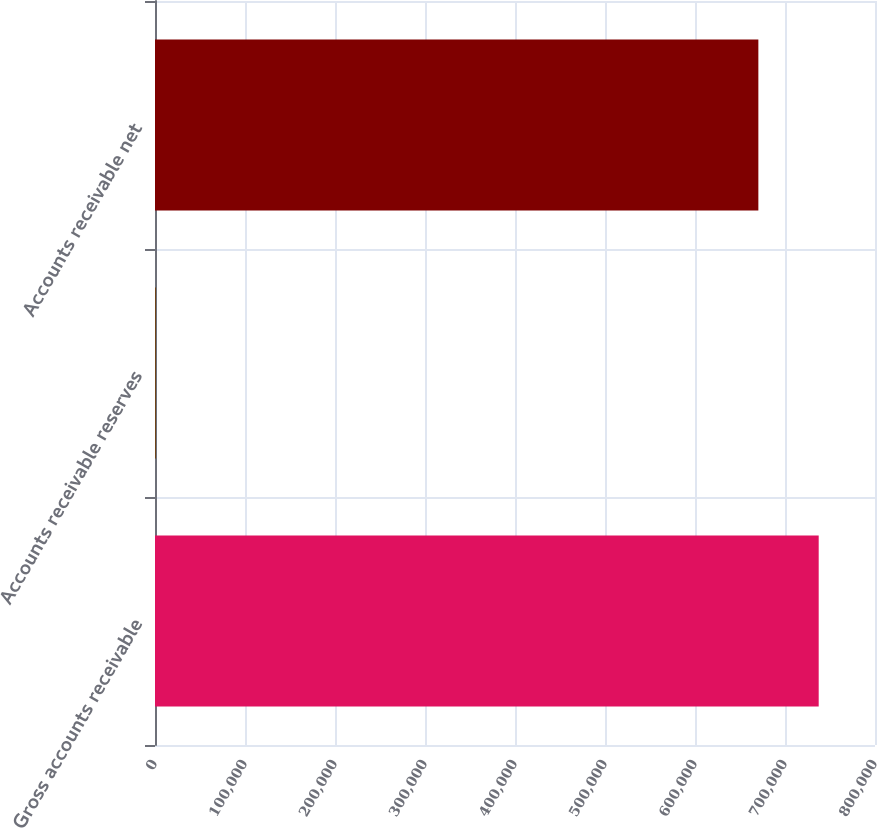Convert chart. <chart><loc_0><loc_0><loc_500><loc_500><bar_chart><fcel>Gross accounts receivable<fcel>Accounts receivable reserves<fcel>Accounts receivable net<nl><fcel>737442<fcel>1069<fcel>670402<nl></chart> 